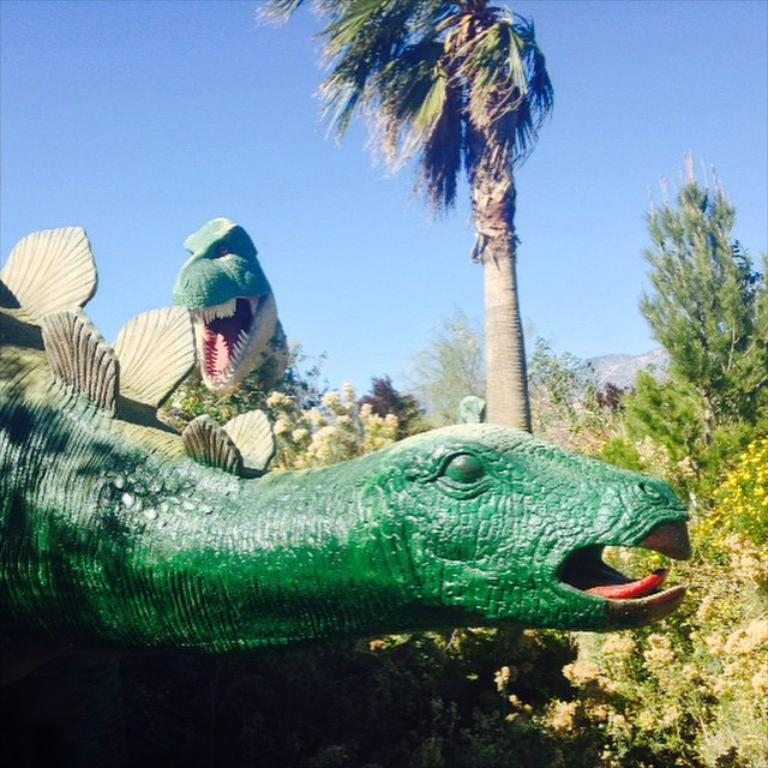What type of objects are depicted as statues in the image? There are statues of animals in the image. What other living organisms can be seen in the image besides the statues? There are plants and trees in the image. Where is the cushion placed in the image? There is no cushion present in the image. What type of animal can be seen in the image besides the statues? There are no other animals visible in the image besides the statues. 